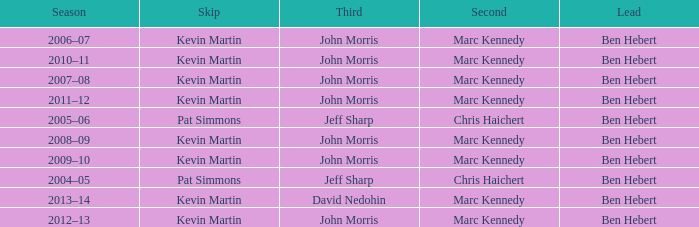What lead has the third David Nedohin? Ben Hebert. 